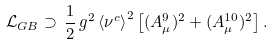Convert formula to latex. <formula><loc_0><loc_0><loc_500><loc_500>\mathcal { L } _ { G B } \supset \, \frac { 1 } { 2 } \, g ^ { 2 } \, { \langle \nu ^ { c } \rangle } ^ { 2 } \left [ ( A _ { \mu } ^ { 9 } ) ^ { 2 } + ( A _ { \mu } ^ { 1 0 } ) ^ { 2 } \right ] .</formula> 